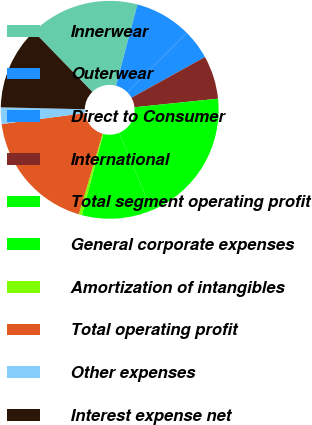Convert chart. <chart><loc_0><loc_0><loc_500><loc_500><pie_chart><fcel>Innerwear<fcel>Outerwear<fcel>Direct to Consumer<fcel>International<fcel>Total segment operating profit<fcel>General corporate expenses<fcel>Amortization of intangibles<fcel>Total operating profit<fcel>Other expenses<fcel>Interest expense net<nl><fcel>16.36%<fcel>8.41%<fcel>4.44%<fcel>6.42%<fcel>20.33%<fcel>10.4%<fcel>0.46%<fcel>18.35%<fcel>2.45%<fcel>12.38%<nl></chart> 